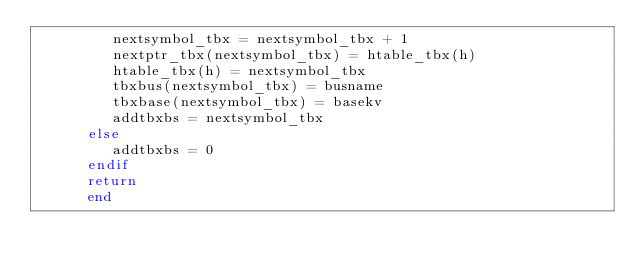<code> <loc_0><loc_0><loc_500><loc_500><_FORTRAN_>         nextsymbol_tbx = nextsymbol_tbx + 1
         nextptr_tbx(nextsymbol_tbx) = htable_tbx(h)
         htable_tbx(h) = nextsymbol_tbx
         tbxbus(nextsymbol_tbx) = busname
         tbxbase(nextsymbol_tbx) = basekv
         addtbxbs = nextsymbol_tbx
      else
         addtbxbs = 0
      endif
      return
      end
</code> 